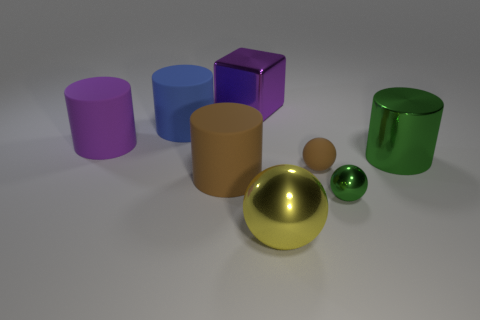Are there any objects in the image that stand out to you, and why? The gold sphere stands out due to its reflective surface and its prominent placement in the foreground, drawing the viewer's eye with its lustrous finish and contrast with the other objects. 